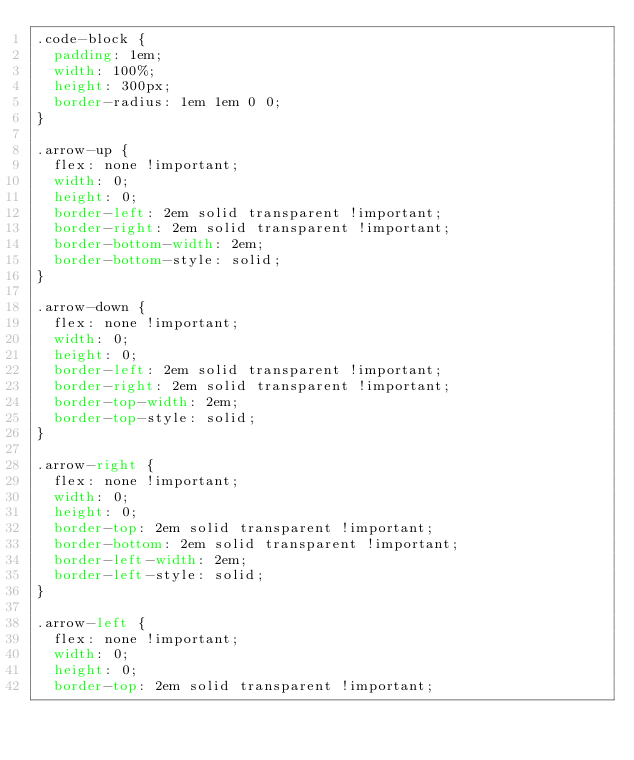Convert code to text. <code><loc_0><loc_0><loc_500><loc_500><_CSS_>.code-block {
  padding: 1em;
  width: 100%;
  height: 300px;
  border-radius: 1em 1em 0 0;
}

.arrow-up {
  flex: none !important;
  width: 0;
  height: 0;
  border-left: 2em solid transparent !important;
  border-right: 2em solid transparent !important;
  border-bottom-width: 2em;
  border-bottom-style: solid;
}

.arrow-down {
  flex: none !important;
  width: 0;
  height: 0;
  border-left: 2em solid transparent !important;
  border-right: 2em solid transparent !important;
  border-top-width: 2em;
  border-top-style: solid;
}

.arrow-right {
  flex: none !important;
  width: 0;
  height: 0;
  border-top: 2em solid transparent !important;
  border-bottom: 2em solid transparent !important;
  border-left-width: 2em;
  border-left-style: solid;
}

.arrow-left {
  flex: none !important;
  width: 0;
  height: 0;
  border-top: 2em solid transparent !important;</code> 